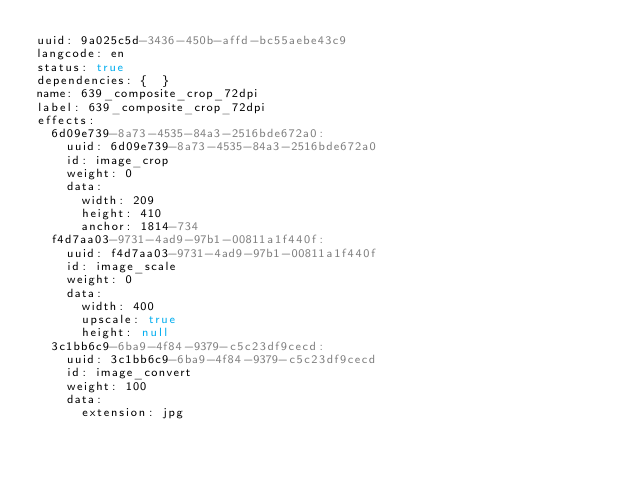Convert code to text. <code><loc_0><loc_0><loc_500><loc_500><_YAML_>uuid: 9a025c5d-3436-450b-affd-bc55aebe43c9
langcode: en
status: true
dependencies: {  }
name: 639_composite_crop_72dpi
label: 639_composite_crop_72dpi
effects:
  6d09e739-8a73-4535-84a3-2516bde672a0:
    uuid: 6d09e739-8a73-4535-84a3-2516bde672a0
    id: image_crop
    weight: 0
    data:
      width: 209
      height: 410
      anchor: 1814-734
  f4d7aa03-9731-4ad9-97b1-00811a1f440f:
    uuid: f4d7aa03-9731-4ad9-97b1-00811a1f440f
    id: image_scale
    weight: 0
    data:
      width: 400
      upscale: true
      height: null
  3c1bb6c9-6ba9-4f84-9379-c5c23df9cecd:
    uuid: 3c1bb6c9-6ba9-4f84-9379-c5c23df9cecd
    id: image_convert
    weight: 100
    data:
      extension: jpg
</code> 